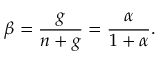<formula> <loc_0><loc_0><loc_500><loc_500>\beta = \frac { g } { n + g } = \frac { \alpha } { 1 + \alpha } .</formula> 